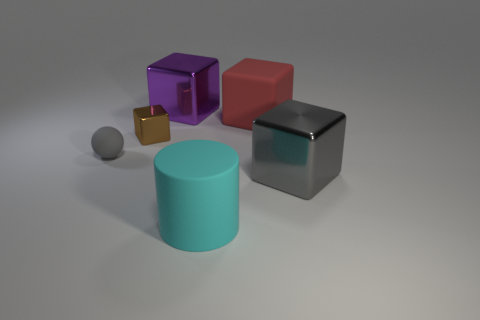Subtract all rubber blocks. How many blocks are left? 3 Subtract all gray blocks. How many blocks are left? 3 Add 2 purple rubber cubes. How many objects exist? 8 Subtract 2 blocks. How many blocks are left? 2 Subtract all blocks. How many objects are left? 2 Subtract all gray cubes. Subtract all cyan cylinders. How many cubes are left? 3 Add 6 big gray rubber spheres. How many big gray rubber spheres exist? 6 Subtract 0 gray cylinders. How many objects are left? 6 Subtract all large red rubber things. Subtract all big purple metal objects. How many objects are left? 4 Add 5 purple blocks. How many purple blocks are left? 6 